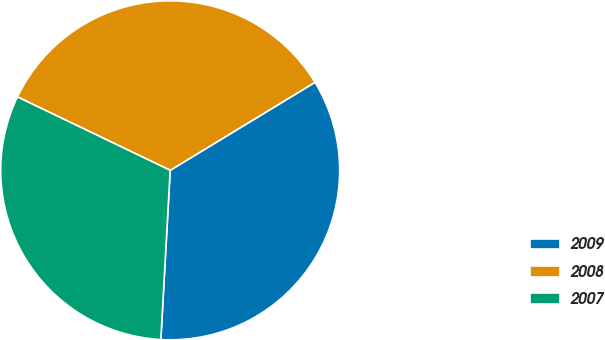Convert chart. <chart><loc_0><loc_0><loc_500><loc_500><pie_chart><fcel>2009<fcel>2008<fcel>2007<nl><fcel>34.57%<fcel>34.18%<fcel>31.25%<nl></chart> 